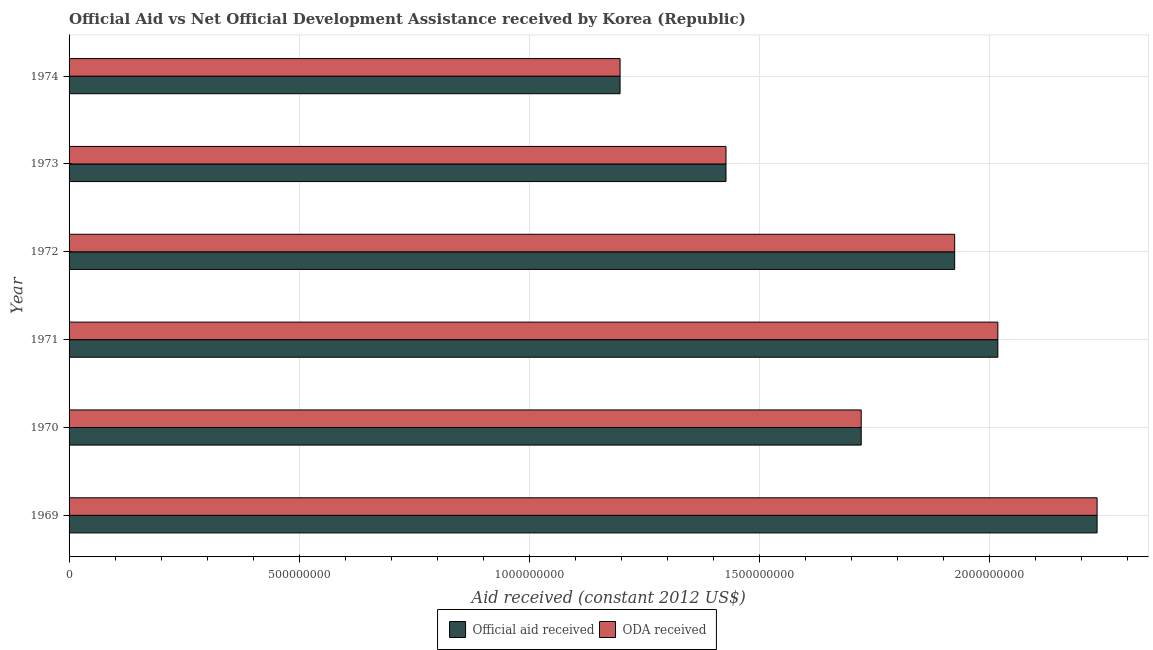How many different coloured bars are there?
Provide a short and direct response. 2. How many groups of bars are there?
Your answer should be compact. 6. Are the number of bars per tick equal to the number of legend labels?
Provide a succinct answer. Yes. How many bars are there on the 5th tick from the top?
Your response must be concise. 2. How many bars are there on the 1st tick from the bottom?
Keep it short and to the point. 2. What is the label of the 3rd group of bars from the top?
Make the answer very short. 1972. What is the official aid received in 1973?
Offer a terse response. 1.43e+09. Across all years, what is the maximum oda received?
Give a very brief answer. 2.23e+09. Across all years, what is the minimum oda received?
Keep it short and to the point. 1.20e+09. In which year was the oda received maximum?
Keep it short and to the point. 1969. In which year was the official aid received minimum?
Your answer should be compact. 1974. What is the total oda received in the graph?
Your response must be concise. 1.05e+1. What is the difference between the oda received in 1972 and that in 1974?
Provide a short and direct response. 7.27e+08. What is the difference between the official aid received in 1971 and the oda received in 1969?
Keep it short and to the point. -2.16e+08. What is the average oda received per year?
Your response must be concise. 1.75e+09. What is the ratio of the oda received in 1969 to that in 1971?
Provide a short and direct response. 1.11. What is the difference between the highest and the second highest official aid received?
Your answer should be compact. 2.16e+08. What is the difference between the highest and the lowest oda received?
Give a very brief answer. 1.04e+09. In how many years, is the oda received greater than the average oda received taken over all years?
Provide a short and direct response. 3. Is the sum of the official aid received in 1970 and 1973 greater than the maximum oda received across all years?
Make the answer very short. Yes. What does the 2nd bar from the top in 1974 represents?
Your response must be concise. Official aid received. What does the 1st bar from the bottom in 1973 represents?
Ensure brevity in your answer.  Official aid received. How many years are there in the graph?
Offer a very short reply. 6. What is the difference between two consecutive major ticks on the X-axis?
Give a very brief answer. 5.00e+08. What is the title of the graph?
Ensure brevity in your answer.  Official Aid vs Net Official Development Assistance received by Korea (Republic) . Does "ODA received" appear as one of the legend labels in the graph?
Offer a very short reply. Yes. What is the label or title of the X-axis?
Provide a succinct answer. Aid received (constant 2012 US$). What is the label or title of the Y-axis?
Ensure brevity in your answer.  Year. What is the Aid received (constant 2012 US$) of Official aid received in 1969?
Your answer should be compact. 2.23e+09. What is the Aid received (constant 2012 US$) in ODA received in 1969?
Offer a very short reply. 2.23e+09. What is the Aid received (constant 2012 US$) of Official aid received in 1970?
Make the answer very short. 1.72e+09. What is the Aid received (constant 2012 US$) of ODA received in 1970?
Keep it short and to the point. 1.72e+09. What is the Aid received (constant 2012 US$) of Official aid received in 1971?
Your answer should be very brief. 2.02e+09. What is the Aid received (constant 2012 US$) in ODA received in 1971?
Give a very brief answer. 2.02e+09. What is the Aid received (constant 2012 US$) of Official aid received in 1972?
Make the answer very short. 1.92e+09. What is the Aid received (constant 2012 US$) of ODA received in 1972?
Give a very brief answer. 1.92e+09. What is the Aid received (constant 2012 US$) in Official aid received in 1973?
Your response must be concise. 1.43e+09. What is the Aid received (constant 2012 US$) of ODA received in 1973?
Your answer should be compact. 1.43e+09. What is the Aid received (constant 2012 US$) in Official aid received in 1974?
Ensure brevity in your answer.  1.20e+09. What is the Aid received (constant 2012 US$) of ODA received in 1974?
Provide a succinct answer. 1.20e+09. Across all years, what is the maximum Aid received (constant 2012 US$) of Official aid received?
Ensure brevity in your answer.  2.23e+09. Across all years, what is the maximum Aid received (constant 2012 US$) of ODA received?
Give a very brief answer. 2.23e+09. Across all years, what is the minimum Aid received (constant 2012 US$) of Official aid received?
Provide a short and direct response. 1.20e+09. Across all years, what is the minimum Aid received (constant 2012 US$) of ODA received?
Your answer should be very brief. 1.20e+09. What is the total Aid received (constant 2012 US$) in Official aid received in the graph?
Provide a succinct answer. 1.05e+1. What is the total Aid received (constant 2012 US$) in ODA received in the graph?
Provide a short and direct response. 1.05e+1. What is the difference between the Aid received (constant 2012 US$) in Official aid received in 1969 and that in 1970?
Keep it short and to the point. 5.12e+08. What is the difference between the Aid received (constant 2012 US$) in ODA received in 1969 and that in 1970?
Your answer should be compact. 5.12e+08. What is the difference between the Aid received (constant 2012 US$) of Official aid received in 1969 and that in 1971?
Offer a terse response. 2.16e+08. What is the difference between the Aid received (constant 2012 US$) in ODA received in 1969 and that in 1971?
Offer a terse response. 2.16e+08. What is the difference between the Aid received (constant 2012 US$) in Official aid received in 1969 and that in 1972?
Your answer should be very brief. 3.09e+08. What is the difference between the Aid received (constant 2012 US$) of ODA received in 1969 and that in 1972?
Provide a short and direct response. 3.09e+08. What is the difference between the Aid received (constant 2012 US$) in Official aid received in 1969 and that in 1973?
Make the answer very short. 8.06e+08. What is the difference between the Aid received (constant 2012 US$) in ODA received in 1969 and that in 1973?
Ensure brevity in your answer.  8.06e+08. What is the difference between the Aid received (constant 2012 US$) in Official aid received in 1969 and that in 1974?
Offer a very short reply. 1.04e+09. What is the difference between the Aid received (constant 2012 US$) of ODA received in 1969 and that in 1974?
Provide a succinct answer. 1.04e+09. What is the difference between the Aid received (constant 2012 US$) in Official aid received in 1970 and that in 1971?
Your answer should be very brief. -2.97e+08. What is the difference between the Aid received (constant 2012 US$) of ODA received in 1970 and that in 1971?
Give a very brief answer. -2.97e+08. What is the difference between the Aid received (constant 2012 US$) of Official aid received in 1970 and that in 1972?
Keep it short and to the point. -2.03e+08. What is the difference between the Aid received (constant 2012 US$) of ODA received in 1970 and that in 1972?
Your response must be concise. -2.03e+08. What is the difference between the Aid received (constant 2012 US$) of Official aid received in 1970 and that in 1973?
Keep it short and to the point. 2.94e+08. What is the difference between the Aid received (constant 2012 US$) in ODA received in 1970 and that in 1973?
Your answer should be very brief. 2.94e+08. What is the difference between the Aid received (constant 2012 US$) in Official aid received in 1970 and that in 1974?
Provide a succinct answer. 5.24e+08. What is the difference between the Aid received (constant 2012 US$) in ODA received in 1970 and that in 1974?
Offer a terse response. 5.24e+08. What is the difference between the Aid received (constant 2012 US$) of Official aid received in 1971 and that in 1972?
Provide a succinct answer. 9.38e+07. What is the difference between the Aid received (constant 2012 US$) of ODA received in 1971 and that in 1972?
Offer a very short reply. 9.38e+07. What is the difference between the Aid received (constant 2012 US$) in Official aid received in 1971 and that in 1973?
Give a very brief answer. 5.91e+08. What is the difference between the Aid received (constant 2012 US$) of ODA received in 1971 and that in 1973?
Your answer should be compact. 5.91e+08. What is the difference between the Aid received (constant 2012 US$) in Official aid received in 1971 and that in 1974?
Offer a terse response. 8.21e+08. What is the difference between the Aid received (constant 2012 US$) of ODA received in 1971 and that in 1974?
Your answer should be very brief. 8.21e+08. What is the difference between the Aid received (constant 2012 US$) of Official aid received in 1972 and that in 1973?
Make the answer very short. 4.97e+08. What is the difference between the Aid received (constant 2012 US$) of ODA received in 1972 and that in 1973?
Give a very brief answer. 4.97e+08. What is the difference between the Aid received (constant 2012 US$) of Official aid received in 1972 and that in 1974?
Your response must be concise. 7.27e+08. What is the difference between the Aid received (constant 2012 US$) in ODA received in 1972 and that in 1974?
Your answer should be compact. 7.27e+08. What is the difference between the Aid received (constant 2012 US$) of Official aid received in 1973 and that in 1974?
Your response must be concise. 2.30e+08. What is the difference between the Aid received (constant 2012 US$) in ODA received in 1973 and that in 1974?
Make the answer very short. 2.30e+08. What is the difference between the Aid received (constant 2012 US$) in Official aid received in 1969 and the Aid received (constant 2012 US$) in ODA received in 1970?
Ensure brevity in your answer.  5.12e+08. What is the difference between the Aid received (constant 2012 US$) in Official aid received in 1969 and the Aid received (constant 2012 US$) in ODA received in 1971?
Keep it short and to the point. 2.16e+08. What is the difference between the Aid received (constant 2012 US$) in Official aid received in 1969 and the Aid received (constant 2012 US$) in ODA received in 1972?
Your response must be concise. 3.09e+08. What is the difference between the Aid received (constant 2012 US$) in Official aid received in 1969 and the Aid received (constant 2012 US$) in ODA received in 1973?
Your response must be concise. 8.06e+08. What is the difference between the Aid received (constant 2012 US$) of Official aid received in 1969 and the Aid received (constant 2012 US$) of ODA received in 1974?
Offer a terse response. 1.04e+09. What is the difference between the Aid received (constant 2012 US$) in Official aid received in 1970 and the Aid received (constant 2012 US$) in ODA received in 1971?
Your answer should be very brief. -2.97e+08. What is the difference between the Aid received (constant 2012 US$) of Official aid received in 1970 and the Aid received (constant 2012 US$) of ODA received in 1972?
Your answer should be compact. -2.03e+08. What is the difference between the Aid received (constant 2012 US$) in Official aid received in 1970 and the Aid received (constant 2012 US$) in ODA received in 1973?
Your answer should be very brief. 2.94e+08. What is the difference between the Aid received (constant 2012 US$) of Official aid received in 1970 and the Aid received (constant 2012 US$) of ODA received in 1974?
Provide a short and direct response. 5.24e+08. What is the difference between the Aid received (constant 2012 US$) of Official aid received in 1971 and the Aid received (constant 2012 US$) of ODA received in 1972?
Your answer should be compact. 9.38e+07. What is the difference between the Aid received (constant 2012 US$) of Official aid received in 1971 and the Aid received (constant 2012 US$) of ODA received in 1973?
Ensure brevity in your answer.  5.91e+08. What is the difference between the Aid received (constant 2012 US$) of Official aid received in 1971 and the Aid received (constant 2012 US$) of ODA received in 1974?
Provide a short and direct response. 8.21e+08. What is the difference between the Aid received (constant 2012 US$) of Official aid received in 1972 and the Aid received (constant 2012 US$) of ODA received in 1973?
Provide a succinct answer. 4.97e+08. What is the difference between the Aid received (constant 2012 US$) of Official aid received in 1972 and the Aid received (constant 2012 US$) of ODA received in 1974?
Provide a succinct answer. 7.27e+08. What is the difference between the Aid received (constant 2012 US$) of Official aid received in 1973 and the Aid received (constant 2012 US$) of ODA received in 1974?
Provide a short and direct response. 2.30e+08. What is the average Aid received (constant 2012 US$) in Official aid received per year?
Offer a terse response. 1.75e+09. What is the average Aid received (constant 2012 US$) in ODA received per year?
Make the answer very short. 1.75e+09. In the year 1972, what is the difference between the Aid received (constant 2012 US$) in Official aid received and Aid received (constant 2012 US$) in ODA received?
Offer a terse response. 0. What is the ratio of the Aid received (constant 2012 US$) in Official aid received in 1969 to that in 1970?
Ensure brevity in your answer.  1.3. What is the ratio of the Aid received (constant 2012 US$) of ODA received in 1969 to that in 1970?
Provide a succinct answer. 1.3. What is the ratio of the Aid received (constant 2012 US$) in Official aid received in 1969 to that in 1971?
Your answer should be very brief. 1.11. What is the ratio of the Aid received (constant 2012 US$) of ODA received in 1969 to that in 1971?
Keep it short and to the point. 1.11. What is the ratio of the Aid received (constant 2012 US$) of Official aid received in 1969 to that in 1972?
Offer a very short reply. 1.16. What is the ratio of the Aid received (constant 2012 US$) in ODA received in 1969 to that in 1972?
Offer a terse response. 1.16. What is the ratio of the Aid received (constant 2012 US$) in Official aid received in 1969 to that in 1973?
Offer a very short reply. 1.56. What is the ratio of the Aid received (constant 2012 US$) of ODA received in 1969 to that in 1973?
Provide a succinct answer. 1.56. What is the ratio of the Aid received (constant 2012 US$) in Official aid received in 1969 to that in 1974?
Your answer should be compact. 1.87. What is the ratio of the Aid received (constant 2012 US$) in ODA received in 1969 to that in 1974?
Provide a short and direct response. 1.87. What is the ratio of the Aid received (constant 2012 US$) of Official aid received in 1970 to that in 1971?
Your answer should be very brief. 0.85. What is the ratio of the Aid received (constant 2012 US$) in ODA received in 1970 to that in 1971?
Ensure brevity in your answer.  0.85. What is the ratio of the Aid received (constant 2012 US$) in Official aid received in 1970 to that in 1972?
Your response must be concise. 0.89. What is the ratio of the Aid received (constant 2012 US$) in ODA received in 1970 to that in 1972?
Give a very brief answer. 0.89. What is the ratio of the Aid received (constant 2012 US$) of Official aid received in 1970 to that in 1973?
Provide a succinct answer. 1.21. What is the ratio of the Aid received (constant 2012 US$) of ODA received in 1970 to that in 1973?
Provide a short and direct response. 1.21. What is the ratio of the Aid received (constant 2012 US$) in Official aid received in 1970 to that in 1974?
Ensure brevity in your answer.  1.44. What is the ratio of the Aid received (constant 2012 US$) of ODA received in 1970 to that in 1974?
Your answer should be very brief. 1.44. What is the ratio of the Aid received (constant 2012 US$) of Official aid received in 1971 to that in 1972?
Your answer should be compact. 1.05. What is the ratio of the Aid received (constant 2012 US$) of ODA received in 1971 to that in 1972?
Your response must be concise. 1.05. What is the ratio of the Aid received (constant 2012 US$) in Official aid received in 1971 to that in 1973?
Your answer should be compact. 1.41. What is the ratio of the Aid received (constant 2012 US$) in ODA received in 1971 to that in 1973?
Your response must be concise. 1.41. What is the ratio of the Aid received (constant 2012 US$) in Official aid received in 1971 to that in 1974?
Make the answer very short. 1.69. What is the ratio of the Aid received (constant 2012 US$) of ODA received in 1971 to that in 1974?
Your answer should be very brief. 1.69. What is the ratio of the Aid received (constant 2012 US$) in Official aid received in 1972 to that in 1973?
Your answer should be compact. 1.35. What is the ratio of the Aid received (constant 2012 US$) in ODA received in 1972 to that in 1973?
Make the answer very short. 1.35. What is the ratio of the Aid received (constant 2012 US$) of Official aid received in 1972 to that in 1974?
Keep it short and to the point. 1.61. What is the ratio of the Aid received (constant 2012 US$) in ODA received in 1972 to that in 1974?
Offer a terse response. 1.61. What is the ratio of the Aid received (constant 2012 US$) of Official aid received in 1973 to that in 1974?
Give a very brief answer. 1.19. What is the ratio of the Aid received (constant 2012 US$) of ODA received in 1973 to that in 1974?
Make the answer very short. 1.19. What is the difference between the highest and the second highest Aid received (constant 2012 US$) of Official aid received?
Keep it short and to the point. 2.16e+08. What is the difference between the highest and the second highest Aid received (constant 2012 US$) in ODA received?
Make the answer very short. 2.16e+08. What is the difference between the highest and the lowest Aid received (constant 2012 US$) of Official aid received?
Your response must be concise. 1.04e+09. What is the difference between the highest and the lowest Aid received (constant 2012 US$) in ODA received?
Offer a terse response. 1.04e+09. 